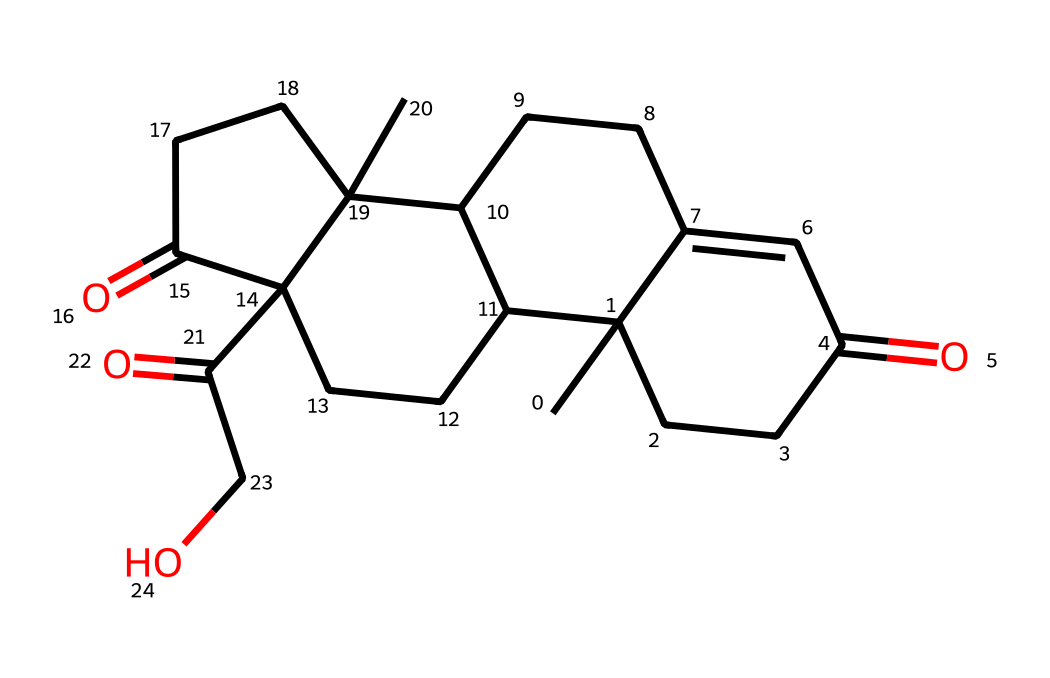What is the molecular formula of cortisone? To determine the molecular formula from the SMILES representation, we can count the number of each type of atom present in the structure. The SMILES indicates there are 21 carbon atoms, 30 hydrogen atoms, and 5 oxygen atoms. Thus, the molecular formula is C21H30O5.
Answer: C21H30O5 How many rings are present in the cortisone structure? By analyzing the structure derived from the SMILES, we can identify the number of cyclic components. Specifically, there are four distinct ring structures formed in cortisone.
Answer: 4 Does cortisone contain any functional groups? Looking at the molecular structure inferred from the SMILES, functional groups such as ketones (C=O) and hydroxyl (–OH) are present. The presence of these groups classifies it as a steroidal structure with functional characteristics.
Answer: Yes What type of chemical classification does cortisone fall under? Based on its structural features, cortisone is classified as a steroid due to its characteristic four-ring structure, inclusive of functional groups that govern its medicinal properties.
Answer: steroid What is the significance of the ketone functional group in cortisone's structure? The ketone functional group in cortisone, indicated by the C=O bonds, is critical for its biological activity. It plays a key role in the anti-inflammatory properties by interacting with biological receptors and mediating metabolic processes.
Answer: anti-inflammatory Which carbon atoms are part of the carbonyl groups in cortisone? Looking at the structure from the SMILES, the carbonyl (C=O) groups appear at positions where carbon atoms are doubly bonded to oxygen. It can be identified by their specific placements in the structural mapping of cortisone, specifically at C3, C11, and C20.
Answer: C3, C11, C20 What is the role of hydroxyl groups in the activity of cortisone? The hydroxyl groups, represented in the structure, are essential for hydrophilicity, allowing cortisone to interact with water-soluble environments in the body, thus influencing its bioavailability and effectiveness in treating inflammation.
Answer: bioavailability 